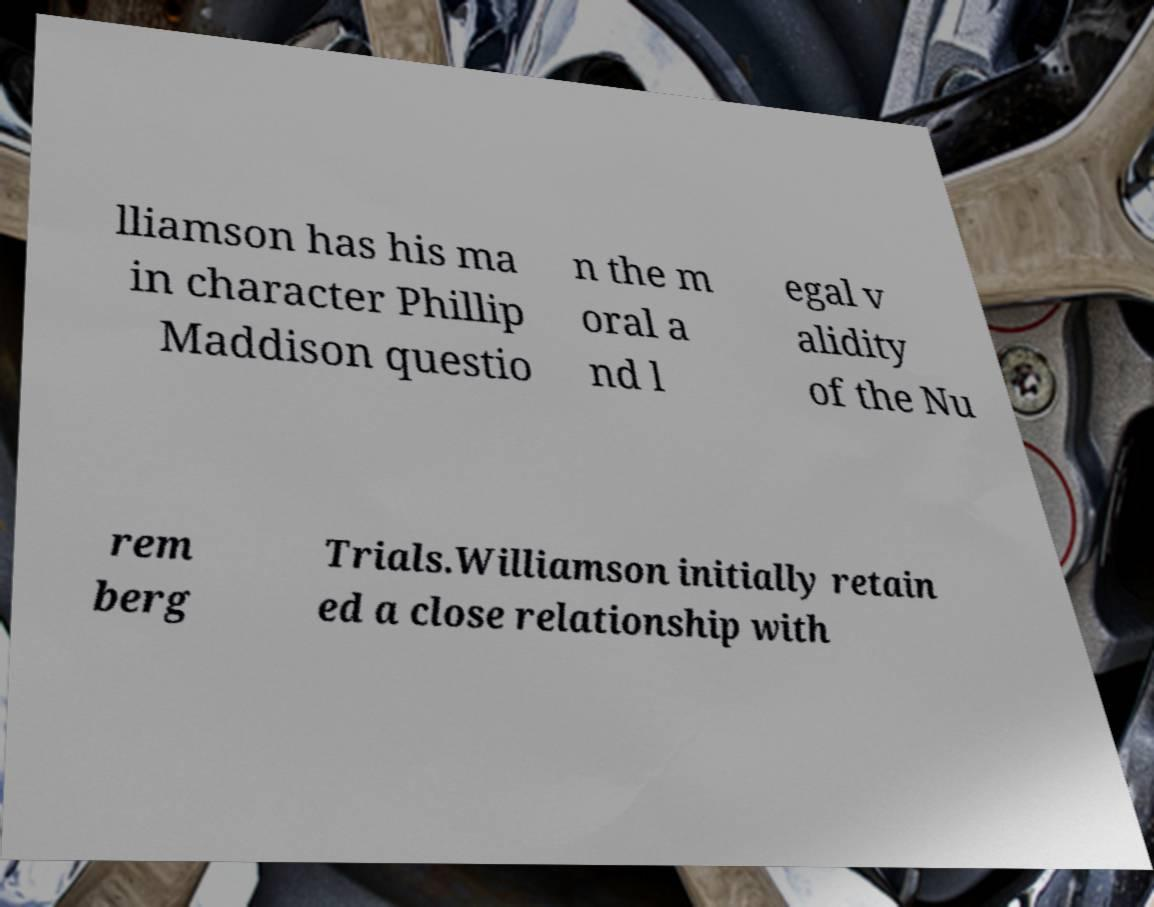Can you read and provide the text displayed in the image?This photo seems to have some interesting text. Can you extract and type it out for me? lliamson has his ma in character Phillip Maddison questio n the m oral a nd l egal v alidity of the Nu rem berg Trials.Williamson initially retain ed a close relationship with 